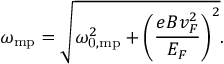Convert formula to latex. <formula><loc_0><loc_0><loc_500><loc_500>\omega _ { m p } = \sqrt { \omega _ { 0 , m p } ^ { 2 } + \left ( \frac { e B v _ { F } ^ { 2 } } { E _ { F } } \right ) ^ { 2 } } .</formula> 